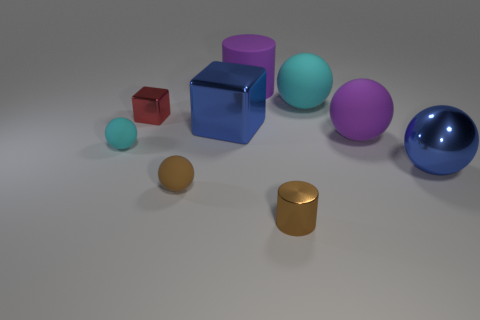Subtract all cyan rubber spheres. How many spheres are left? 3 Subtract all green blocks. How many cyan spheres are left? 2 Add 1 small brown balls. How many objects exist? 10 Subtract 2 spheres. How many spheres are left? 3 Subtract all blue spheres. How many spheres are left? 4 Subtract all spheres. How many objects are left? 4 Subtract all gray spheres. Subtract all purple cubes. How many spheres are left? 5 Add 6 metal cubes. How many metal cubes are left? 8 Add 4 small cylinders. How many small cylinders exist? 5 Subtract 1 brown spheres. How many objects are left? 8 